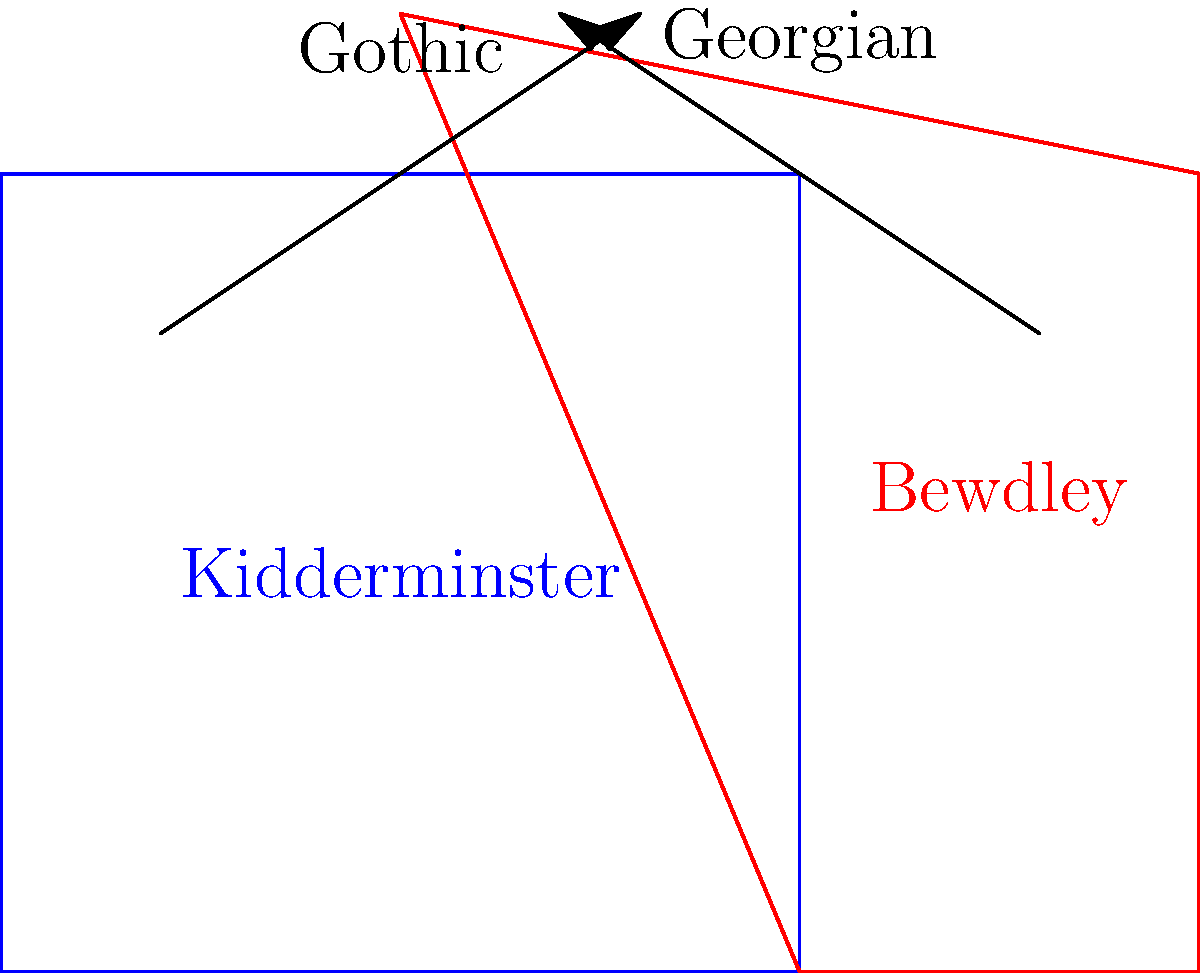Based on the simplified sketches of architectural styles in Kidderminster and Bewdley, which town is more likely to feature pointed arches and flying buttresses in its historic buildings? To answer this question, let's analyze the architectural styles represented in the sketches:

1. Kidderminster (blue sketch):
   - The building has a rectangular shape with a flat roof.
   - There are no visible pointed arches or elaborate decorations.
   - This simple, functional design is more characteristic of Georgian architecture.

2. Bewdley (red sketch):
   - The building has a more complex shape with a pointed roof.
   - The top of the structure resembles a pointed arch.
   - This design is more indicative of Gothic architecture.

3. Architectural features:
   - Pointed arches are a key feature of Gothic architecture, not typically found in Georgian buildings.
   - Flying buttresses, external supports used to distribute the weight of the roof, are also associated with Gothic architecture.

4. Historical context:
   - Gothic architecture predates Georgian, being popular from the 12th to 16th centuries.
   - Georgian architecture was prevalent in the 18th and early 19th centuries.

5. Conclusion:
   - Based on the sketches, Bewdley's architectural style is more closely aligned with Gothic features.
   - Therefore, Bewdley is more likely to feature pointed arches and flying buttresses in its historic buildings.
Answer: Bewdley 